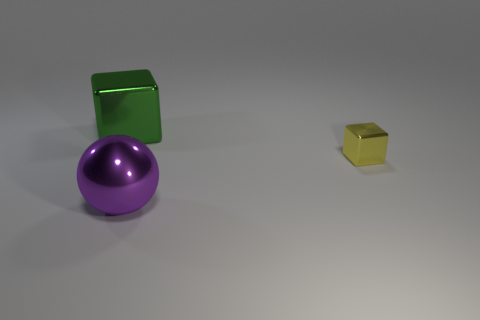Add 3 green objects. How many objects exist? 6 Subtract all cubes. How many objects are left? 1 Add 2 spheres. How many spheres are left? 3 Add 2 large green rubber cylinders. How many large green rubber cylinders exist? 2 Subtract 1 green cubes. How many objects are left? 2 Subtract all cubes. Subtract all spheres. How many objects are left? 0 